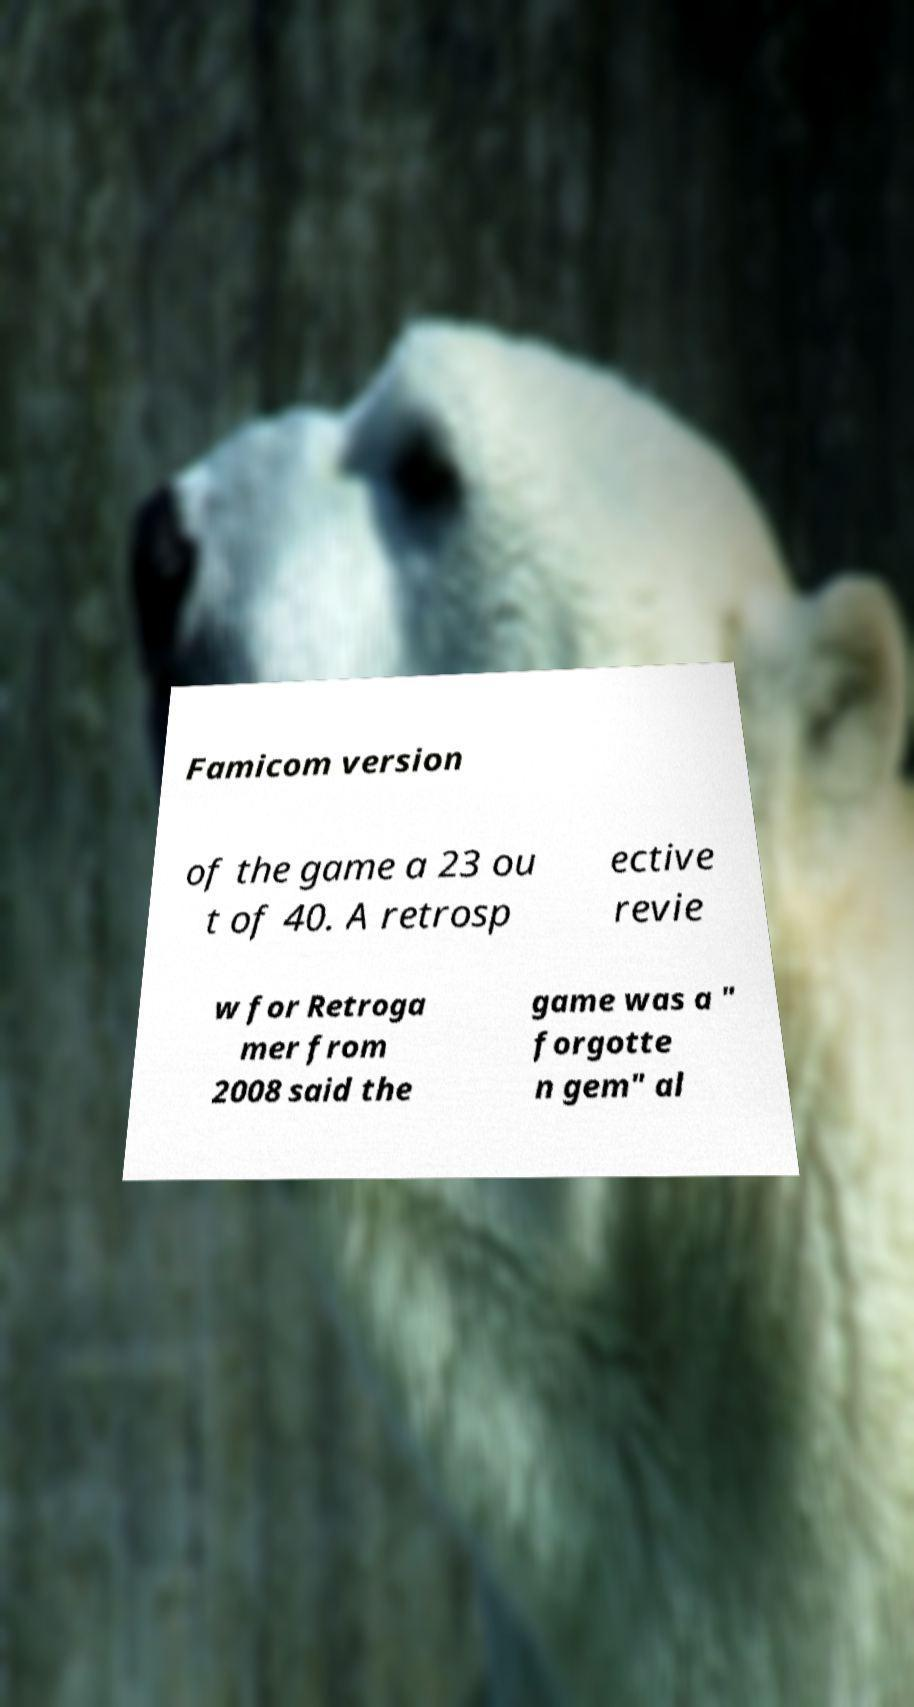Can you accurately transcribe the text from the provided image for me? Famicom version of the game a 23 ou t of 40. A retrosp ective revie w for Retroga mer from 2008 said the game was a " forgotte n gem" al 